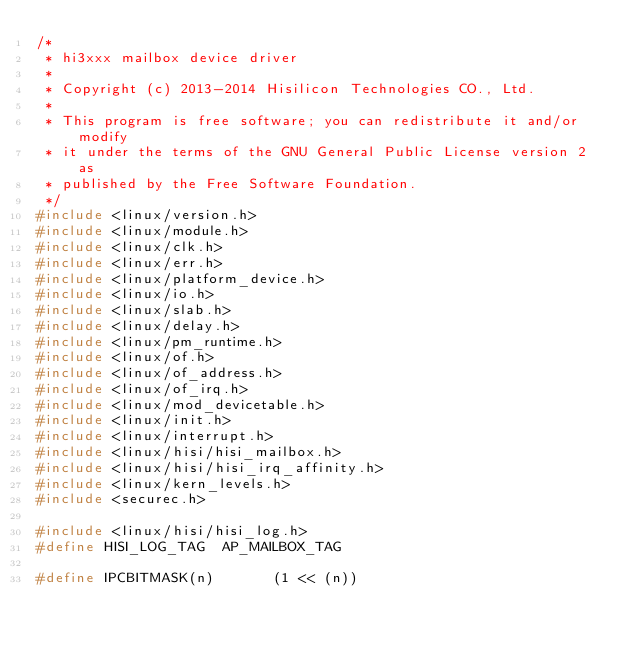<code> <loc_0><loc_0><loc_500><loc_500><_C_>/*
 * hi3xxx mailbox device driver
 *
 * Copyright (c) 2013-2014 Hisilicon Technologies CO., Ltd.
 *
 * This program is free software; you can redistribute it and/or modify
 * it under the terms of the GNU General Public License version 2 as
 * published by the Free Software Foundation.
 */
#include <linux/version.h>
#include <linux/module.h>
#include <linux/clk.h>
#include <linux/err.h>
#include <linux/platform_device.h>
#include <linux/io.h>
#include <linux/slab.h>
#include <linux/delay.h>
#include <linux/pm_runtime.h>
#include <linux/of.h>
#include <linux/of_address.h>
#include <linux/of_irq.h>
#include <linux/mod_devicetable.h>
#include <linux/init.h>
#include <linux/interrupt.h>
#include <linux/hisi/hisi_mailbox.h>
#include <linux/hisi/hisi_irq_affinity.h>
#include <linux/kern_levels.h>
#include <securec.h>

#include <linux/hisi/hisi_log.h>
#define HISI_LOG_TAG	AP_MAILBOX_TAG

#define IPCBITMASK(n)				(1 << (n))</code> 